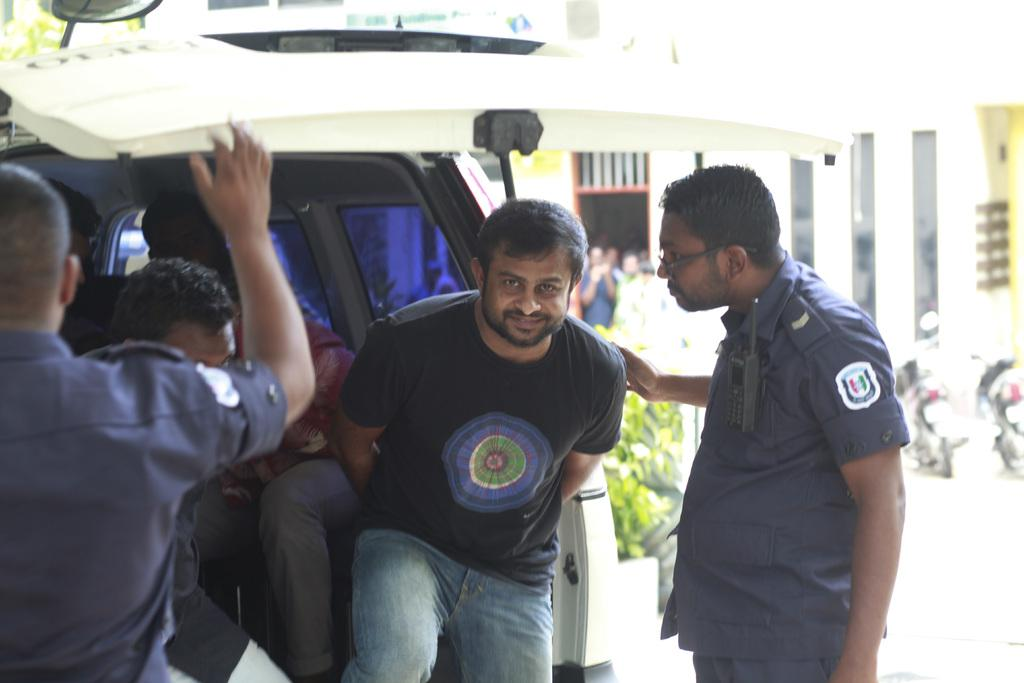How many people are in the image? There are people in the image, but the exact number is not specified. What is the man in the image wearing? The man in the image is wearing a uniform. What device is attached to the man's uniform? The man in uniform has a walkie talkie on his chest. What can be seen in the background of the image? There are vehicles and a building in the background of the image. What type of plants can be seen growing in the crib in the image? There is no crib or plants present in the image. What type of fuel is being used by the vehicles in the background? The type of fuel being used by the vehicles in the background is not specified in the image. 